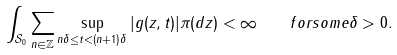Convert formula to latex. <formula><loc_0><loc_0><loc_500><loc_500>\int _ { { \mathcal { S } } _ { 0 } } \sum _ { n \in { \mathbb { Z } } } \sup _ { n \delta \leq t < ( n + 1 ) \delta } | g ( z , t ) | \pi ( d z ) < \infty \quad f o r s o m e \delta > 0 .</formula> 